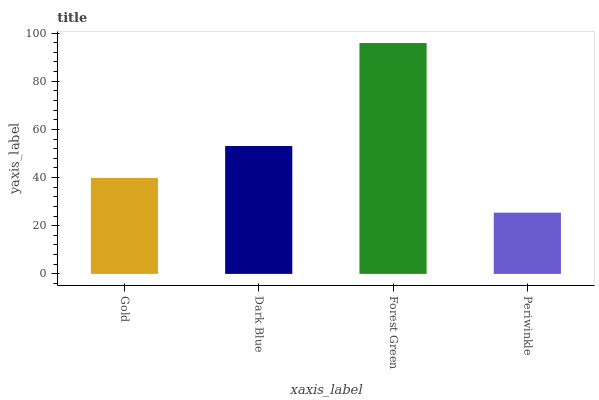Is Periwinkle the minimum?
Answer yes or no. Yes. Is Forest Green the maximum?
Answer yes or no. Yes. Is Dark Blue the minimum?
Answer yes or no. No. Is Dark Blue the maximum?
Answer yes or no. No. Is Dark Blue greater than Gold?
Answer yes or no. Yes. Is Gold less than Dark Blue?
Answer yes or no. Yes. Is Gold greater than Dark Blue?
Answer yes or no. No. Is Dark Blue less than Gold?
Answer yes or no. No. Is Dark Blue the high median?
Answer yes or no. Yes. Is Gold the low median?
Answer yes or no. Yes. Is Forest Green the high median?
Answer yes or no. No. Is Dark Blue the low median?
Answer yes or no. No. 